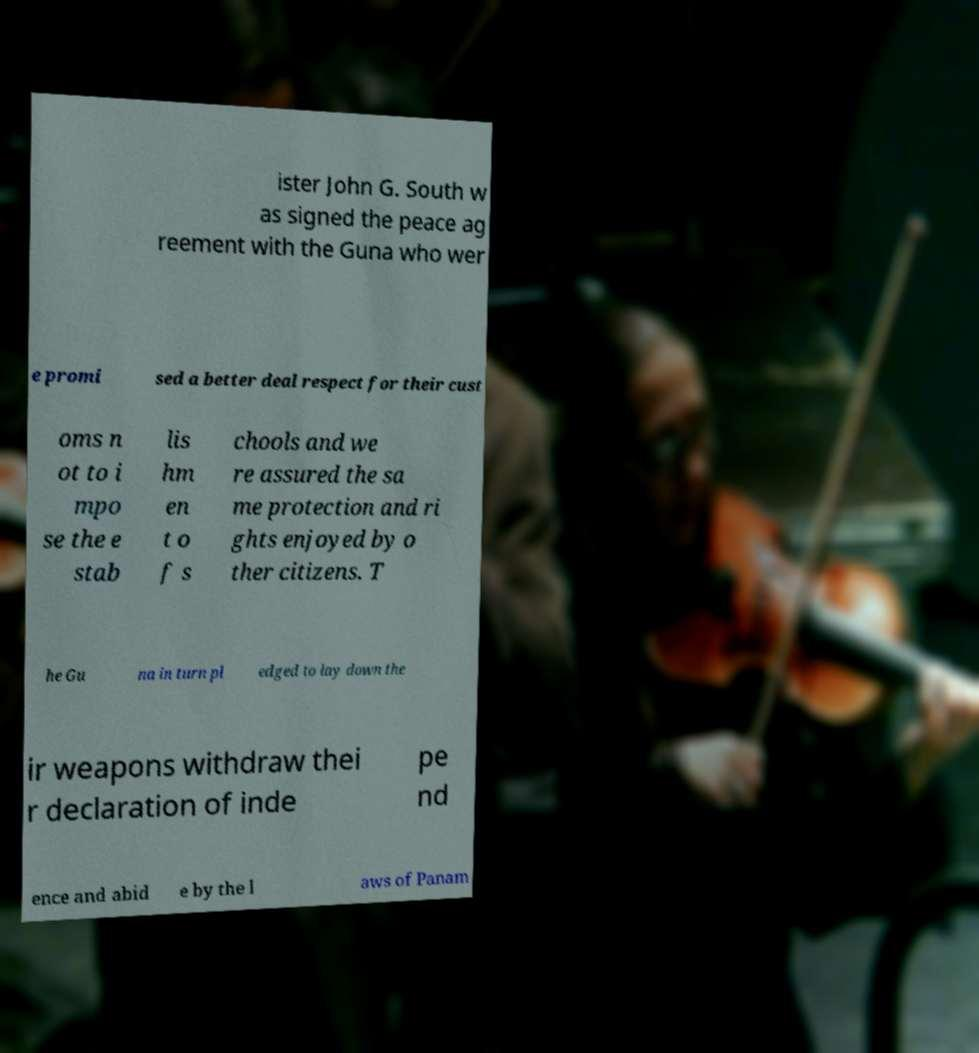I need the written content from this picture converted into text. Can you do that? ister John G. South w as signed the peace ag reement with the Guna who wer e promi sed a better deal respect for their cust oms n ot to i mpo se the e stab lis hm en t o f s chools and we re assured the sa me protection and ri ghts enjoyed by o ther citizens. T he Gu na in turn pl edged to lay down the ir weapons withdraw thei r declaration of inde pe nd ence and abid e by the l aws of Panam 